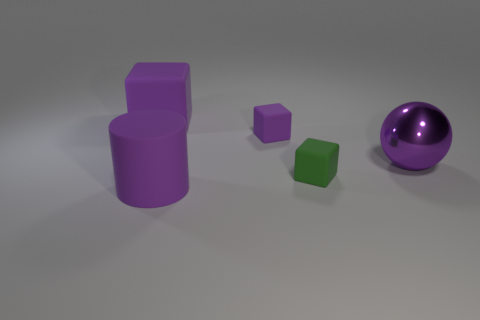Subtract all purple cubes. How many were subtracted if there are1purple cubes left? 1 Subtract all purple rubber cubes. How many cubes are left? 1 Add 4 shiny balls. How many objects exist? 9 Subtract all green cubes. How many cubes are left? 2 Subtract all balls. How many objects are left? 4 Subtract 0 blue spheres. How many objects are left? 5 Subtract 2 blocks. How many blocks are left? 1 Subtract all blue spheres. Subtract all red cubes. How many spheres are left? 1 Subtract all cyan cylinders. How many purple blocks are left? 2 Subtract all yellow matte cylinders. Subtract all purple rubber blocks. How many objects are left? 3 